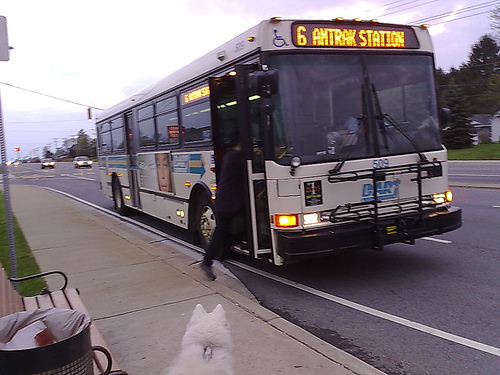Please provide a short description for this region: [0.58, 0.16, 0.86, 0.23]. The indicated region, [0.58, 0.16, 0.86, 0.23], displays vibrant yellow letters on the sign, possibly providing important information or directions. 